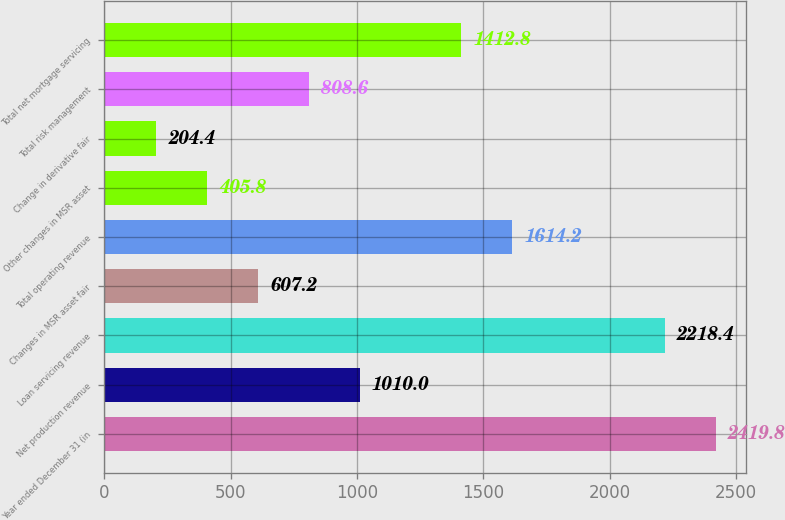Convert chart to OTSL. <chart><loc_0><loc_0><loc_500><loc_500><bar_chart><fcel>Year ended December 31 (in<fcel>Net production revenue<fcel>Loan servicing revenue<fcel>Changes in MSR asset fair<fcel>Total operating revenue<fcel>Other changes in MSR asset<fcel>Change in derivative fair<fcel>Total risk management<fcel>Total net mortgage servicing<nl><fcel>2419.8<fcel>1010<fcel>2218.4<fcel>607.2<fcel>1614.2<fcel>405.8<fcel>204.4<fcel>808.6<fcel>1412.8<nl></chart> 